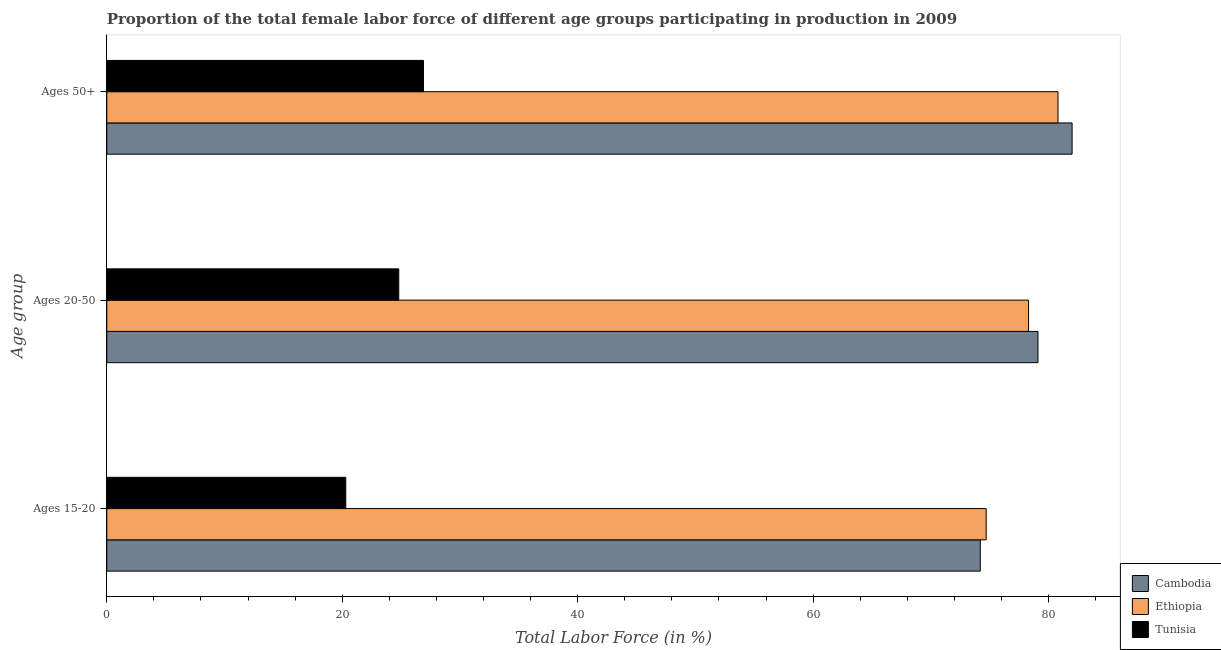How many different coloured bars are there?
Give a very brief answer. 3. How many groups of bars are there?
Your answer should be very brief. 3. Are the number of bars per tick equal to the number of legend labels?
Your response must be concise. Yes. Are the number of bars on each tick of the Y-axis equal?
Give a very brief answer. Yes. How many bars are there on the 3rd tick from the top?
Your answer should be compact. 3. How many bars are there on the 3rd tick from the bottom?
Give a very brief answer. 3. What is the label of the 2nd group of bars from the top?
Your response must be concise. Ages 20-50. What is the percentage of female labor force within the age group 20-50 in Cambodia?
Make the answer very short. 79.1. Across all countries, what is the maximum percentage of female labor force within the age group 20-50?
Provide a short and direct response. 79.1. Across all countries, what is the minimum percentage of female labor force within the age group 15-20?
Offer a very short reply. 20.3. In which country was the percentage of female labor force within the age group 20-50 maximum?
Ensure brevity in your answer.  Cambodia. In which country was the percentage of female labor force within the age group 15-20 minimum?
Keep it short and to the point. Tunisia. What is the total percentage of female labor force within the age group 20-50 in the graph?
Provide a succinct answer. 182.2. What is the difference between the percentage of female labor force within the age group 20-50 in Tunisia and that in Cambodia?
Your answer should be compact. -54.3. What is the difference between the percentage of female labor force within the age group 15-20 in Cambodia and the percentage of female labor force above age 50 in Ethiopia?
Provide a short and direct response. -6.6. What is the average percentage of female labor force within the age group 15-20 per country?
Keep it short and to the point. 56.4. What is the difference between the percentage of female labor force within the age group 20-50 and percentage of female labor force above age 50 in Ethiopia?
Give a very brief answer. -2.5. What is the ratio of the percentage of female labor force within the age group 15-20 in Ethiopia to that in Tunisia?
Make the answer very short. 3.68. Is the percentage of female labor force above age 50 in Ethiopia less than that in Cambodia?
Provide a succinct answer. Yes. Is the difference between the percentage of female labor force within the age group 15-20 in Ethiopia and Tunisia greater than the difference between the percentage of female labor force within the age group 20-50 in Ethiopia and Tunisia?
Keep it short and to the point. Yes. What is the difference between the highest and the second highest percentage of female labor force above age 50?
Provide a succinct answer. 1.2. What is the difference between the highest and the lowest percentage of female labor force within the age group 15-20?
Your response must be concise. 54.4. Is the sum of the percentage of female labor force above age 50 in Cambodia and Ethiopia greater than the maximum percentage of female labor force within the age group 20-50 across all countries?
Your answer should be very brief. Yes. What does the 1st bar from the top in Ages 15-20 represents?
Your answer should be compact. Tunisia. What does the 1st bar from the bottom in Ages 15-20 represents?
Offer a terse response. Cambodia. How many bars are there?
Offer a terse response. 9. Are all the bars in the graph horizontal?
Keep it short and to the point. Yes. How many countries are there in the graph?
Offer a terse response. 3. Does the graph contain any zero values?
Your response must be concise. No. How many legend labels are there?
Keep it short and to the point. 3. How are the legend labels stacked?
Give a very brief answer. Vertical. What is the title of the graph?
Your answer should be compact. Proportion of the total female labor force of different age groups participating in production in 2009. What is the label or title of the Y-axis?
Offer a very short reply. Age group. What is the Total Labor Force (in %) of Cambodia in Ages 15-20?
Your answer should be very brief. 74.2. What is the Total Labor Force (in %) of Ethiopia in Ages 15-20?
Make the answer very short. 74.7. What is the Total Labor Force (in %) in Tunisia in Ages 15-20?
Your response must be concise. 20.3. What is the Total Labor Force (in %) of Cambodia in Ages 20-50?
Ensure brevity in your answer.  79.1. What is the Total Labor Force (in %) in Ethiopia in Ages 20-50?
Offer a terse response. 78.3. What is the Total Labor Force (in %) in Tunisia in Ages 20-50?
Make the answer very short. 24.8. What is the Total Labor Force (in %) in Ethiopia in Ages 50+?
Make the answer very short. 80.8. What is the Total Labor Force (in %) of Tunisia in Ages 50+?
Offer a terse response. 26.9. Across all Age group, what is the maximum Total Labor Force (in %) of Cambodia?
Give a very brief answer. 82. Across all Age group, what is the maximum Total Labor Force (in %) in Ethiopia?
Your answer should be very brief. 80.8. Across all Age group, what is the maximum Total Labor Force (in %) in Tunisia?
Provide a short and direct response. 26.9. Across all Age group, what is the minimum Total Labor Force (in %) of Cambodia?
Make the answer very short. 74.2. Across all Age group, what is the minimum Total Labor Force (in %) in Ethiopia?
Keep it short and to the point. 74.7. Across all Age group, what is the minimum Total Labor Force (in %) of Tunisia?
Provide a succinct answer. 20.3. What is the total Total Labor Force (in %) of Cambodia in the graph?
Offer a very short reply. 235.3. What is the total Total Labor Force (in %) in Ethiopia in the graph?
Provide a short and direct response. 233.8. What is the difference between the Total Labor Force (in %) in Ethiopia in Ages 15-20 and that in Ages 20-50?
Your answer should be compact. -3.6. What is the difference between the Total Labor Force (in %) of Tunisia in Ages 15-20 and that in Ages 50+?
Provide a succinct answer. -6.6. What is the difference between the Total Labor Force (in %) in Cambodia in Ages 20-50 and that in Ages 50+?
Give a very brief answer. -2.9. What is the difference between the Total Labor Force (in %) in Tunisia in Ages 20-50 and that in Ages 50+?
Your answer should be very brief. -2.1. What is the difference between the Total Labor Force (in %) in Cambodia in Ages 15-20 and the Total Labor Force (in %) in Ethiopia in Ages 20-50?
Your response must be concise. -4.1. What is the difference between the Total Labor Force (in %) in Cambodia in Ages 15-20 and the Total Labor Force (in %) in Tunisia in Ages 20-50?
Provide a short and direct response. 49.4. What is the difference between the Total Labor Force (in %) in Ethiopia in Ages 15-20 and the Total Labor Force (in %) in Tunisia in Ages 20-50?
Your response must be concise. 49.9. What is the difference between the Total Labor Force (in %) of Cambodia in Ages 15-20 and the Total Labor Force (in %) of Ethiopia in Ages 50+?
Keep it short and to the point. -6.6. What is the difference between the Total Labor Force (in %) in Cambodia in Ages 15-20 and the Total Labor Force (in %) in Tunisia in Ages 50+?
Provide a succinct answer. 47.3. What is the difference between the Total Labor Force (in %) in Ethiopia in Ages 15-20 and the Total Labor Force (in %) in Tunisia in Ages 50+?
Ensure brevity in your answer.  47.8. What is the difference between the Total Labor Force (in %) of Cambodia in Ages 20-50 and the Total Labor Force (in %) of Tunisia in Ages 50+?
Your answer should be compact. 52.2. What is the difference between the Total Labor Force (in %) of Ethiopia in Ages 20-50 and the Total Labor Force (in %) of Tunisia in Ages 50+?
Your response must be concise. 51.4. What is the average Total Labor Force (in %) in Cambodia per Age group?
Your response must be concise. 78.43. What is the average Total Labor Force (in %) in Ethiopia per Age group?
Ensure brevity in your answer.  77.93. What is the difference between the Total Labor Force (in %) in Cambodia and Total Labor Force (in %) in Ethiopia in Ages 15-20?
Provide a short and direct response. -0.5. What is the difference between the Total Labor Force (in %) of Cambodia and Total Labor Force (in %) of Tunisia in Ages 15-20?
Your response must be concise. 53.9. What is the difference between the Total Labor Force (in %) of Ethiopia and Total Labor Force (in %) of Tunisia in Ages 15-20?
Your answer should be compact. 54.4. What is the difference between the Total Labor Force (in %) in Cambodia and Total Labor Force (in %) in Tunisia in Ages 20-50?
Offer a terse response. 54.3. What is the difference between the Total Labor Force (in %) in Ethiopia and Total Labor Force (in %) in Tunisia in Ages 20-50?
Provide a succinct answer. 53.5. What is the difference between the Total Labor Force (in %) of Cambodia and Total Labor Force (in %) of Ethiopia in Ages 50+?
Your answer should be very brief. 1.2. What is the difference between the Total Labor Force (in %) in Cambodia and Total Labor Force (in %) in Tunisia in Ages 50+?
Offer a very short reply. 55.1. What is the difference between the Total Labor Force (in %) in Ethiopia and Total Labor Force (in %) in Tunisia in Ages 50+?
Your answer should be very brief. 53.9. What is the ratio of the Total Labor Force (in %) of Cambodia in Ages 15-20 to that in Ages 20-50?
Your answer should be very brief. 0.94. What is the ratio of the Total Labor Force (in %) of Ethiopia in Ages 15-20 to that in Ages 20-50?
Your response must be concise. 0.95. What is the ratio of the Total Labor Force (in %) of Tunisia in Ages 15-20 to that in Ages 20-50?
Offer a very short reply. 0.82. What is the ratio of the Total Labor Force (in %) of Cambodia in Ages 15-20 to that in Ages 50+?
Provide a succinct answer. 0.9. What is the ratio of the Total Labor Force (in %) of Ethiopia in Ages 15-20 to that in Ages 50+?
Give a very brief answer. 0.92. What is the ratio of the Total Labor Force (in %) of Tunisia in Ages 15-20 to that in Ages 50+?
Keep it short and to the point. 0.75. What is the ratio of the Total Labor Force (in %) in Cambodia in Ages 20-50 to that in Ages 50+?
Your answer should be very brief. 0.96. What is the ratio of the Total Labor Force (in %) in Ethiopia in Ages 20-50 to that in Ages 50+?
Provide a short and direct response. 0.97. What is the ratio of the Total Labor Force (in %) of Tunisia in Ages 20-50 to that in Ages 50+?
Give a very brief answer. 0.92. What is the difference between the highest and the second highest Total Labor Force (in %) of Ethiopia?
Provide a short and direct response. 2.5. What is the difference between the highest and the lowest Total Labor Force (in %) in Ethiopia?
Your response must be concise. 6.1. What is the difference between the highest and the lowest Total Labor Force (in %) in Tunisia?
Your answer should be compact. 6.6. 